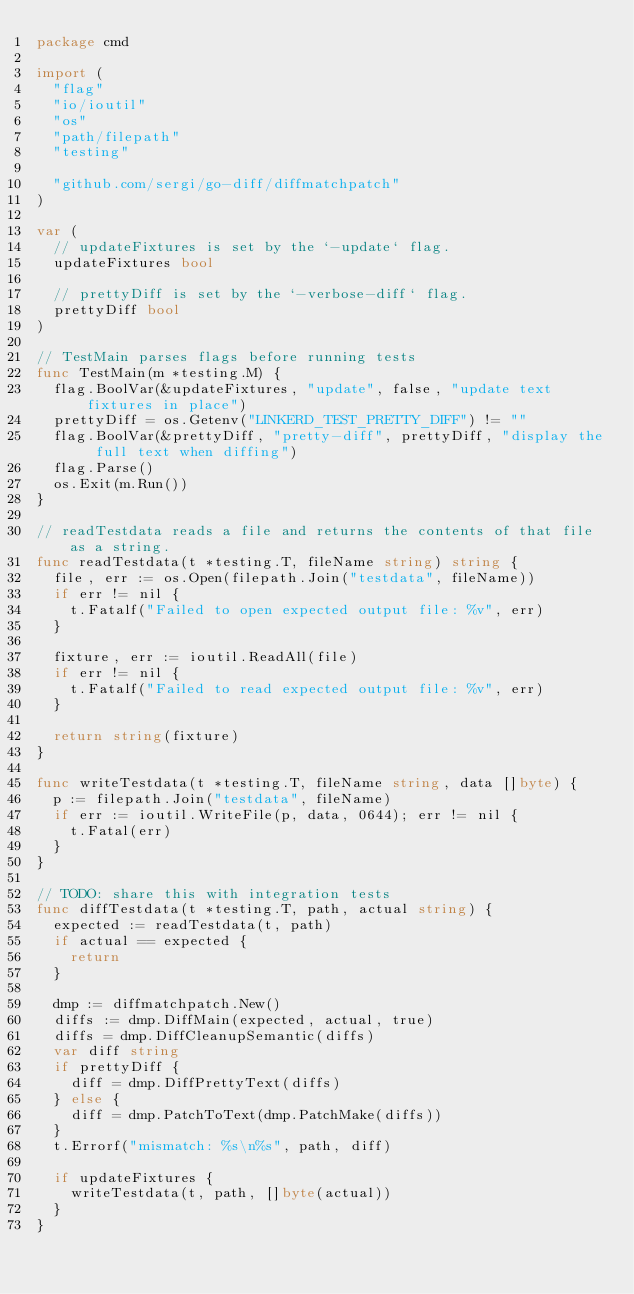Convert code to text. <code><loc_0><loc_0><loc_500><loc_500><_Go_>package cmd

import (
	"flag"
	"io/ioutil"
	"os"
	"path/filepath"
	"testing"

	"github.com/sergi/go-diff/diffmatchpatch"
)

var (
	// updateFixtures is set by the `-update` flag.
	updateFixtures bool

	// prettyDiff is set by the `-verbose-diff` flag.
	prettyDiff bool
)

// TestMain parses flags before running tests
func TestMain(m *testing.M) {
	flag.BoolVar(&updateFixtures, "update", false, "update text fixtures in place")
	prettyDiff = os.Getenv("LINKERD_TEST_PRETTY_DIFF") != ""
	flag.BoolVar(&prettyDiff, "pretty-diff", prettyDiff, "display the full text when diffing")
	flag.Parse()
	os.Exit(m.Run())
}

// readTestdata reads a file and returns the contents of that file as a string.
func readTestdata(t *testing.T, fileName string) string {
	file, err := os.Open(filepath.Join("testdata", fileName))
	if err != nil {
		t.Fatalf("Failed to open expected output file: %v", err)
	}

	fixture, err := ioutil.ReadAll(file)
	if err != nil {
		t.Fatalf("Failed to read expected output file: %v", err)
	}

	return string(fixture)
}

func writeTestdata(t *testing.T, fileName string, data []byte) {
	p := filepath.Join("testdata", fileName)
	if err := ioutil.WriteFile(p, data, 0644); err != nil {
		t.Fatal(err)
	}
}

// TODO: share this with integration tests
func diffTestdata(t *testing.T, path, actual string) {
	expected := readTestdata(t, path)
	if actual == expected {
		return
	}

	dmp := diffmatchpatch.New()
	diffs := dmp.DiffMain(expected, actual, true)
	diffs = dmp.DiffCleanupSemantic(diffs)
	var diff string
	if prettyDiff {
		diff = dmp.DiffPrettyText(diffs)
	} else {
		diff = dmp.PatchToText(dmp.PatchMake(diffs))
	}
	t.Errorf("mismatch: %s\n%s", path, diff)

	if updateFixtures {
		writeTestdata(t, path, []byte(actual))
	}
}
</code> 